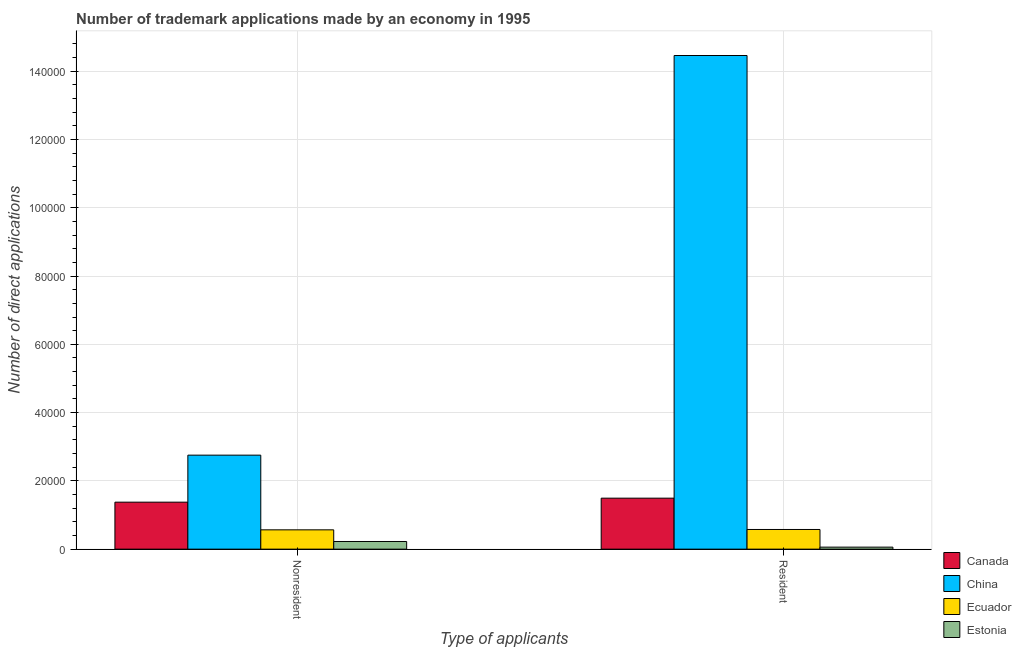Are the number of bars per tick equal to the number of legend labels?
Offer a very short reply. Yes. Are the number of bars on each tick of the X-axis equal?
Your answer should be very brief. Yes. How many bars are there on the 2nd tick from the left?
Make the answer very short. 4. How many bars are there on the 2nd tick from the right?
Ensure brevity in your answer.  4. What is the label of the 1st group of bars from the left?
Your answer should be very brief. Nonresident. What is the number of trademark applications made by non residents in Ecuador?
Your response must be concise. 5657. Across all countries, what is the maximum number of trademark applications made by residents?
Ensure brevity in your answer.  1.45e+05. Across all countries, what is the minimum number of trademark applications made by residents?
Your response must be concise. 589. In which country was the number of trademark applications made by non residents minimum?
Offer a very short reply. Estonia. What is the total number of trademark applications made by non residents in the graph?
Provide a short and direct response. 4.92e+04. What is the difference between the number of trademark applications made by non residents in China and that in Estonia?
Give a very brief answer. 2.53e+04. What is the difference between the number of trademark applications made by non residents in Estonia and the number of trademark applications made by residents in China?
Give a very brief answer. -1.42e+05. What is the average number of trademark applications made by non residents per country?
Offer a terse response. 1.23e+04. What is the difference between the number of trademark applications made by non residents and number of trademark applications made by residents in China?
Give a very brief answer. -1.17e+05. In how many countries, is the number of trademark applications made by non residents greater than 56000 ?
Make the answer very short. 0. What is the ratio of the number of trademark applications made by non residents in Estonia to that in China?
Offer a very short reply. 0.08. In how many countries, is the number of trademark applications made by residents greater than the average number of trademark applications made by residents taken over all countries?
Your response must be concise. 1. What does the 2nd bar from the left in Resident represents?
Offer a very short reply. China. Are all the bars in the graph horizontal?
Your response must be concise. No. How many countries are there in the graph?
Provide a succinct answer. 4. What is the difference between two consecutive major ticks on the Y-axis?
Your answer should be compact. 2.00e+04. Where does the legend appear in the graph?
Ensure brevity in your answer.  Bottom right. How are the legend labels stacked?
Ensure brevity in your answer.  Vertical. What is the title of the graph?
Ensure brevity in your answer.  Number of trademark applications made by an economy in 1995. Does "European Union" appear as one of the legend labels in the graph?
Provide a succinct answer. No. What is the label or title of the X-axis?
Your answer should be compact. Type of applicants. What is the label or title of the Y-axis?
Your answer should be very brief. Number of direct applications. What is the Number of direct applications in Canada in Nonresident?
Give a very brief answer. 1.38e+04. What is the Number of direct applications in China in Nonresident?
Offer a very short reply. 2.75e+04. What is the Number of direct applications of Ecuador in Nonresident?
Ensure brevity in your answer.  5657. What is the Number of direct applications of Estonia in Nonresident?
Offer a very short reply. 2241. What is the Number of direct applications of Canada in Resident?
Provide a short and direct response. 1.49e+04. What is the Number of direct applications in China in Resident?
Your response must be concise. 1.45e+05. What is the Number of direct applications in Ecuador in Resident?
Ensure brevity in your answer.  5763. What is the Number of direct applications of Estonia in Resident?
Ensure brevity in your answer.  589. Across all Type of applicants, what is the maximum Number of direct applications of Canada?
Provide a short and direct response. 1.49e+04. Across all Type of applicants, what is the maximum Number of direct applications in China?
Make the answer very short. 1.45e+05. Across all Type of applicants, what is the maximum Number of direct applications in Ecuador?
Offer a terse response. 5763. Across all Type of applicants, what is the maximum Number of direct applications in Estonia?
Ensure brevity in your answer.  2241. Across all Type of applicants, what is the minimum Number of direct applications of Canada?
Offer a very short reply. 1.38e+04. Across all Type of applicants, what is the minimum Number of direct applications in China?
Your answer should be compact. 2.75e+04. Across all Type of applicants, what is the minimum Number of direct applications in Ecuador?
Ensure brevity in your answer.  5657. Across all Type of applicants, what is the minimum Number of direct applications of Estonia?
Make the answer very short. 589. What is the total Number of direct applications of Canada in the graph?
Your answer should be compact. 2.87e+04. What is the total Number of direct applications in China in the graph?
Offer a very short reply. 1.72e+05. What is the total Number of direct applications in Ecuador in the graph?
Offer a terse response. 1.14e+04. What is the total Number of direct applications of Estonia in the graph?
Provide a short and direct response. 2830. What is the difference between the Number of direct applications of Canada in Nonresident and that in Resident?
Give a very brief answer. -1172. What is the difference between the Number of direct applications of China in Nonresident and that in Resident?
Keep it short and to the point. -1.17e+05. What is the difference between the Number of direct applications of Ecuador in Nonresident and that in Resident?
Offer a terse response. -106. What is the difference between the Number of direct applications in Estonia in Nonresident and that in Resident?
Keep it short and to the point. 1652. What is the difference between the Number of direct applications of Canada in Nonresident and the Number of direct applications of China in Resident?
Offer a terse response. -1.31e+05. What is the difference between the Number of direct applications of Canada in Nonresident and the Number of direct applications of Ecuador in Resident?
Offer a very short reply. 8003. What is the difference between the Number of direct applications in Canada in Nonresident and the Number of direct applications in Estonia in Resident?
Your answer should be very brief. 1.32e+04. What is the difference between the Number of direct applications of China in Nonresident and the Number of direct applications of Ecuador in Resident?
Your response must be concise. 2.18e+04. What is the difference between the Number of direct applications of China in Nonresident and the Number of direct applications of Estonia in Resident?
Ensure brevity in your answer.  2.69e+04. What is the difference between the Number of direct applications of Ecuador in Nonresident and the Number of direct applications of Estonia in Resident?
Your response must be concise. 5068. What is the average Number of direct applications of Canada per Type of applicants?
Provide a short and direct response. 1.44e+04. What is the average Number of direct applications in China per Type of applicants?
Your response must be concise. 8.61e+04. What is the average Number of direct applications in Ecuador per Type of applicants?
Provide a succinct answer. 5710. What is the average Number of direct applications in Estonia per Type of applicants?
Make the answer very short. 1415. What is the difference between the Number of direct applications in Canada and Number of direct applications in China in Nonresident?
Your answer should be compact. -1.38e+04. What is the difference between the Number of direct applications of Canada and Number of direct applications of Ecuador in Nonresident?
Provide a short and direct response. 8109. What is the difference between the Number of direct applications in Canada and Number of direct applications in Estonia in Nonresident?
Offer a terse response. 1.15e+04. What is the difference between the Number of direct applications in China and Number of direct applications in Ecuador in Nonresident?
Your answer should be very brief. 2.19e+04. What is the difference between the Number of direct applications of China and Number of direct applications of Estonia in Nonresident?
Make the answer very short. 2.53e+04. What is the difference between the Number of direct applications of Ecuador and Number of direct applications of Estonia in Nonresident?
Provide a short and direct response. 3416. What is the difference between the Number of direct applications in Canada and Number of direct applications in China in Resident?
Offer a terse response. -1.30e+05. What is the difference between the Number of direct applications in Canada and Number of direct applications in Ecuador in Resident?
Give a very brief answer. 9175. What is the difference between the Number of direct applications in Canada and Number of direct applications in Estonia in Resident?
Your response must be concise. 1.43e+04. What is the difference between the Number of direct applications of China and Number of direct applications of Ecuador in Resident?
Give a very brief answer. 1.39e+05. What is the difference between the Number of direct applications in China and Number of direct applications in Estonia in Resident?
Offer a very short reply. 1.44e+05. What is the difference between the Number of direct applications of Ecuador and Number of direct applications of Estonia in Resident?
Provide a succinct answer. 5174. What is the ratio of the Number of direct applications of Canada in Nonresident to that in Resident?
Your answer should be very brief. 0.92. What is the ratio of the Number of direct applications of China in Nonresident to that in Resident?
Give a very brief answer. 0.19. What is the ratio of the Number of direct applications in Ecuador in Nonresident to that in Resident?
Ensure brevity in your answer.  0.98. What is the ratio of the Number of direct applications in Estonia in Nonresident to that in Resident?
Your response must be concise. 3.8. What is the difference between the highest and the second highest Number of direct applications in Canada?
Keep it short and to the point. 1172. What is the difference between the highest and the second highest Number of direct applications in China?
Keep it short and to the point. 1.17e+05. What is the difference between the highest and the second highest Number of direct applications in Ecuador?
Keep it short and to the point. 106. What is the difference between the highest and the second highest Number of direct applications of Estonia?
Make the answer very short. 1652. What is the difference between the highest and the lowest Number of direct applications of Canada?
Provide a succinct answer. 1172. What is the difference between the highest and the lowest Number of direct applications of China?
Ensure brevity in your answer.  1.17e+05. What is the difference between the highest and the lowest Number of direct applications in Ecuador?
Offer a very short reply. 106. What is the difference between the highest and the lowest Number of direct applications in Estonia?
Make the answer very short. 1652. 